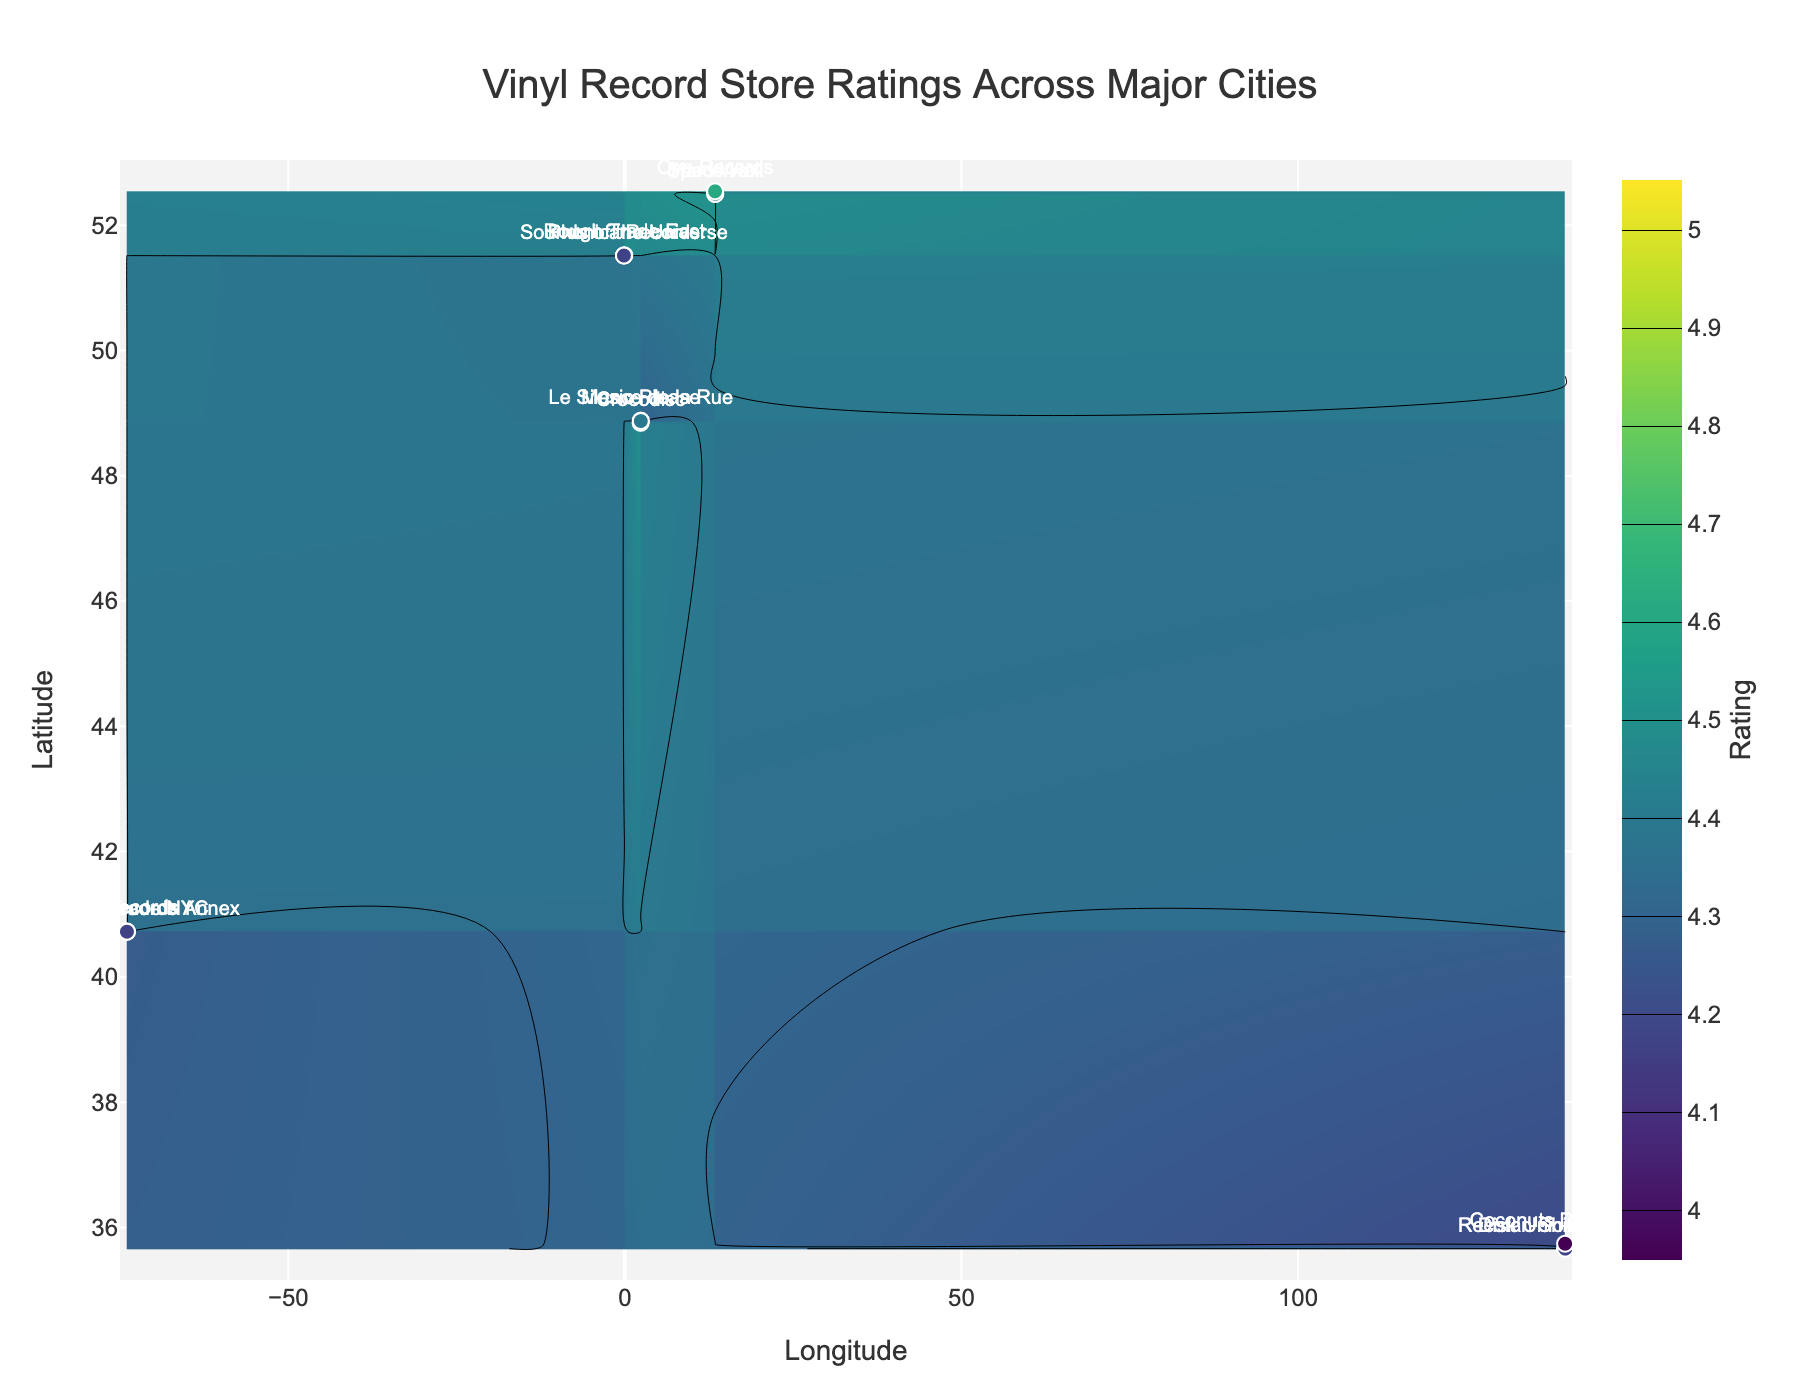How many cities are represented in the figure? The plot mentions different vinyl record stores' locations across various major cities. By counting the unique city names labeled around the stores, we see there are five: New York City, Berlin, Tokyo, London, and Paris.
Answer: 5 What is the overall trend of store ratings in New York City? In New York City, the store ratings are spread between 4.2 and 4.5. This can be noted by observing the contour plot within the latitude and longitude range that represents New York City, along with the specific ratings indicated for each store.
Answer: 4.2 to 4.5 Which city has the highest rated store? To determine this, examine the ratings associated with the stores and locate the highest rating, which is Disk Union Shibuya in Tokyo with a rating of 4.7.
Answer: Tokyo Compare the average ratings of stores in Berlin and London. Calculate the average rating by summing the ratings of the stores in each city and then dividing by the number of stores. Berlin: (4.6 + 4.4 + 4.5) / 3 = 4.5; London: (4.5 + 4.4 + 4.3) / 3 = 4.4. Therefore, Berlin has a higher average rating.
Answer: Berlin Which stores have a rating of exactly 4.4? A close examination of the contoured areas alongside store labels reveals that Space Hall in Berlin, Phonica Records in London, and Music Please in Paris have a rating of exactly 4.4.
Answer: 3 In which city is the store 'Recofan Shibuya BEAM' located, and what is its rating? By observing the scatter plot and store labels, it is visible that Recofan Shibuya BEAM is located in Tokyo with a rating of 4.3.
Answer: Tokyo, 4.3 